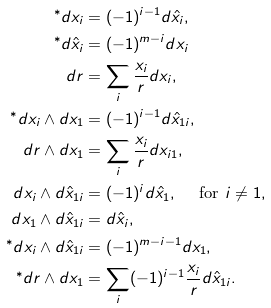Convert formula to latex. <formula><loc_0><loc_0><loc_500><loc_500>^ { * } d x _ { i } & = ( - 1 ) ^ { i - 1 } d \hat { x } _ { i } , \\ ^ { * } d \hat { x } _ { i } & = ( - 1 ) ^ { m - i } d x _ { i } \\ d r & = \sum _ { i } \frac { x _ { i } } r d x _ { i } , \\ ^ { * } d x _ { i } \wedge d x _ { 1 } & = ( - 1 ) ^ { i - 1 } d \hat { x } _ { 1 i } , \\ d r \wedge d x _ { 1 } & = \sum _ { i } \frac { x _ { i } } r d x _ { i 1 } , \\ d x _ { i } \wedge d \hat { x } _ { 1 i } & = ( - 1 ) ^ { i } d \hat { x } _ { 1 } , \quad \text { for } i \neq 1 , \\ d x _ { 1 } \wedge d \hat { x } _ { 1 i } & = d \hat { x } _ { i } , \\ ^ { * } d x _ { i } \wedge d \hat { x } _ { 1 i } & = ( - 1 ) ^ { m - i - 1 } d x _ { 1 } , \\ ^ { * } d r \wedge d x _ { 1 } & = \sum _ { i } ( - 1 ) ^ { i - 1 } \frac { x _ { i } } r d \hat { x } _ { 1 i } .</formula> 